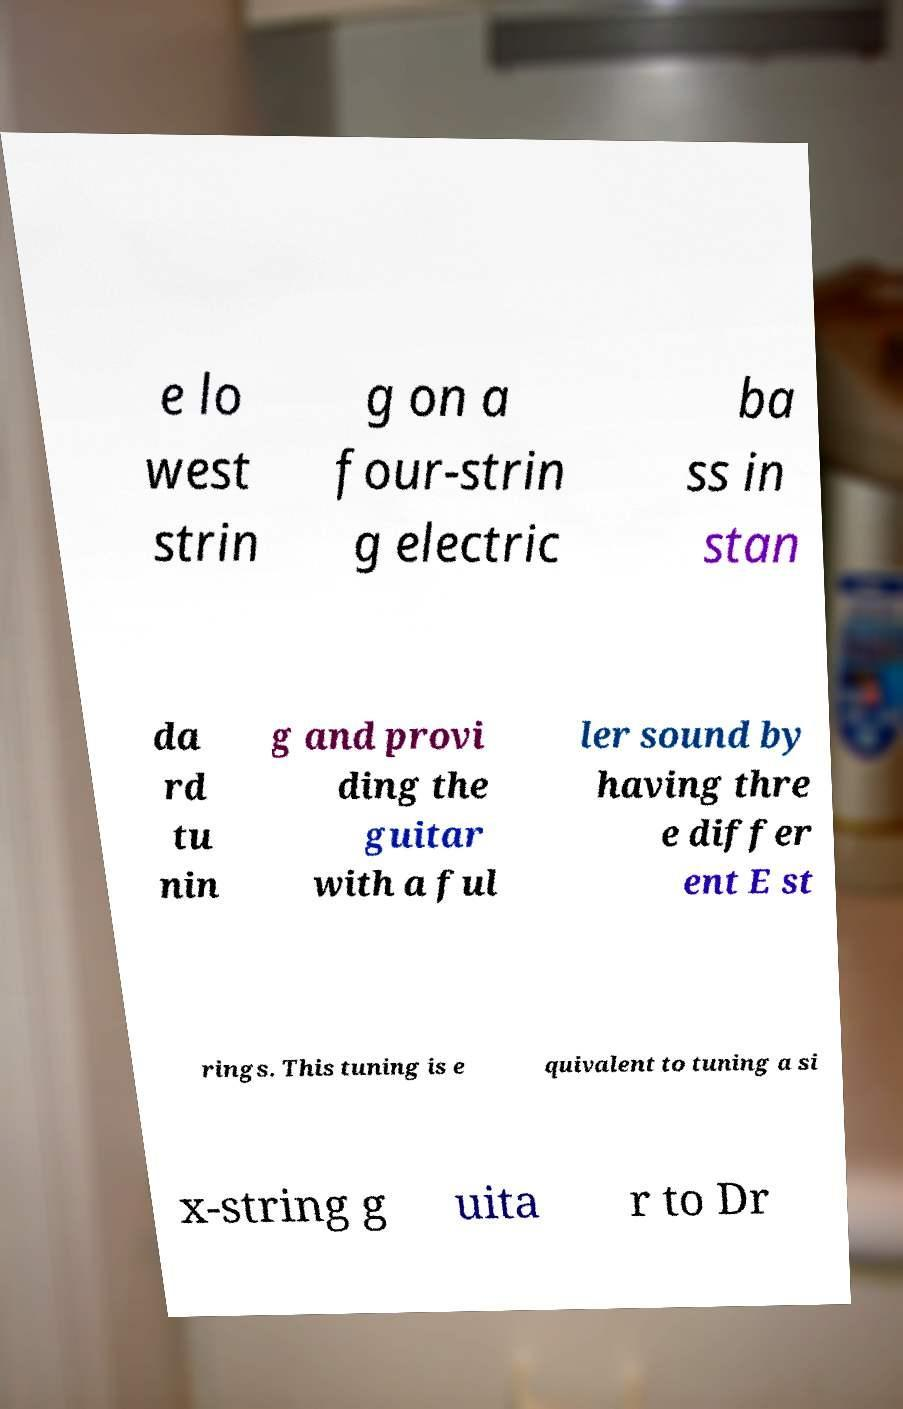What messages or text are displayed in this image? I need them in a readable, typed format. e lo west strin g on a four-strin g electric ba ss in stan da rd tu nin g and provi ding the guitar with a ful ler sound by having thre e differ ent E st rings. This tuning is e quivalent to tuning a si x-string g uita r to Dr 